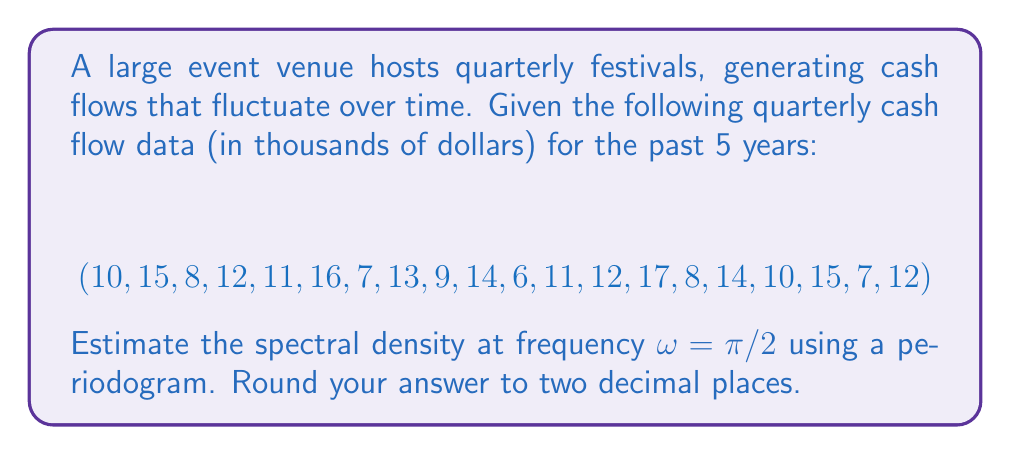Can you solve this math problem? To estimate the spectral density using a periodogram, we'll follow these steps:

1) First, calculate the mean of the time series:
   $$\bar{x} = \frac{1}{N}\sum_{t=1}^N x_t = 11.35$$

2) Subtract the mean from each value to center the series:
   $$y_t = x_t - \bar{x}$$

3) Calculate the discrete Fourier transform (DFT) at $\omega = \pi/2$:
   $$Y(\omega) = \sum_{t=1}^N y_t e^{-i\omega t}$$
   
   At $\omega = \pi/2$:
   $$Y(\pi/2) = \sum_{t=1}^N y_t ((-i)^t)$$

4) Compute the periodogram:
   $$I(\omega) = \frac{1}{2\pi N}|Y(\omega)|^2$$

5) For $\omega = \pi/2$:
   $$Y(\pi/2) = (-1.35 + i) + (3.65 - i) + ... + (0.65 - i) = -4.7 - 3.7i$$

6) Calculate the periodogram:
   $$I(\pi/2) = \frac{1}{2\pi \cdot 20}((-4.7)^2 + (-3.7)^2) = 0.1407$$

7) Round to two decimal places: 0.14

This estimate represents the power spectral density at the frequency $\pi/2$, which corresponds to a cycle of 4 quarters (1 year) in the cash flow data.
Answer: 0.14 